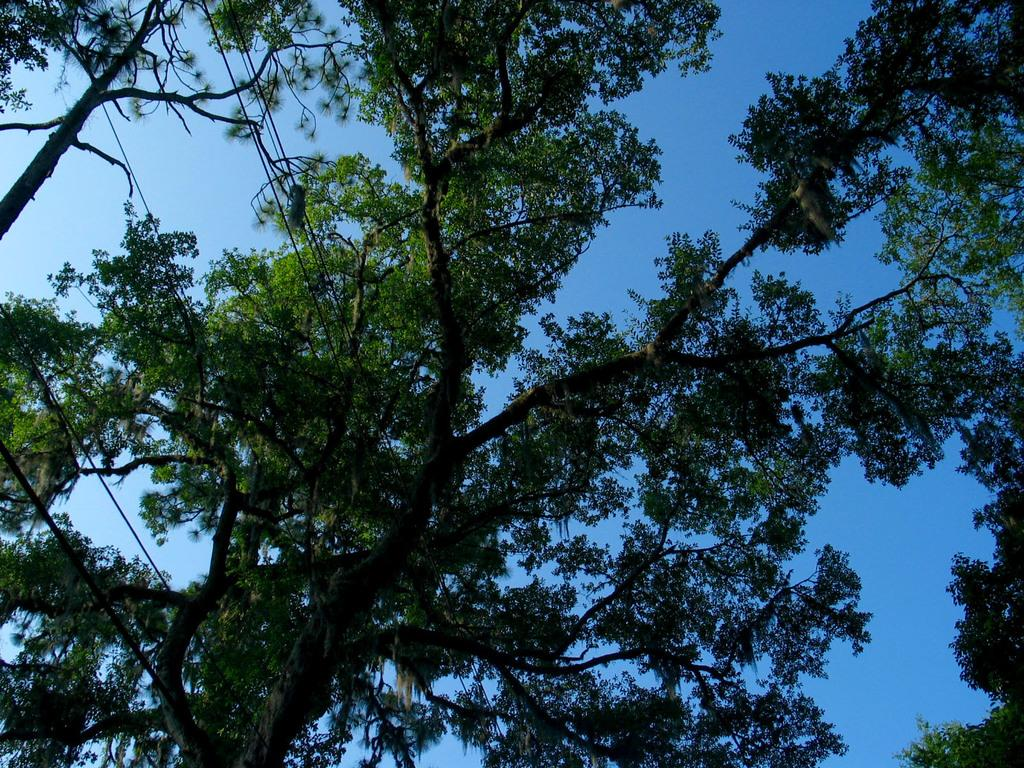What type of vegetation can be seen in the image? There are trees in the image. What else is present in the image besides trees? There are wires in the image. What can be seen in the background of the image? The sky is visible in the image. How many tickets are hanging from the wires in the image? There are no tickets present in the image; only trees and wires are visible. 